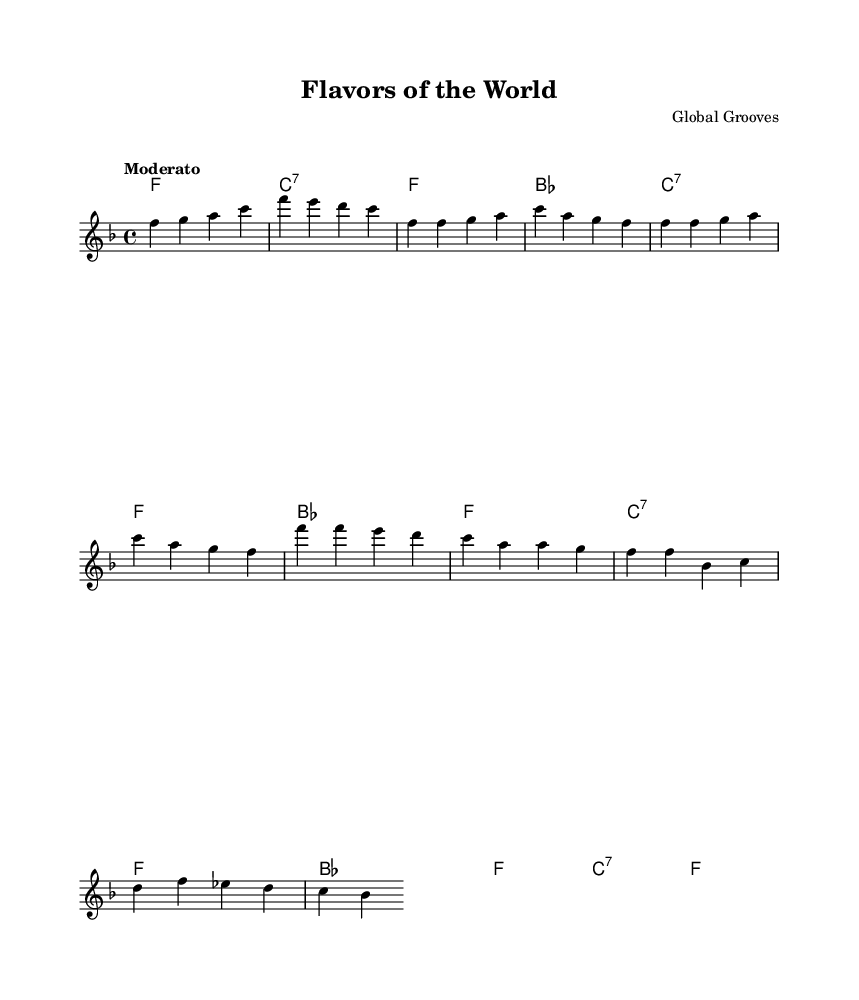What is the key signature of this music? The key signature is F major, which has one flat (B flat).
Answer: F major What is the time signature of this music? The time signature is 4/4, indicating four beats in each measure.
Answer: 4/4 What is the tempo marking for this piece? The tempo marking is "Moderato," which indicates a moderate speed.
Answer: Moderato How many measures are in the chorus section? The chorus section consists of two measures, as indicated by the repeated lines of the lyrics in the score.
Answer: Two Which instruments are indicated in the score layout? The score includes a staff for melody and a section for chord names, typically indicating harmonic support for the melody.
Answer: Melody and chord names What is the main lyrical theme of the song? The song celebrates culinary diversity and global flavors, focusing on the enjoyment of different cuisines.
Answer: Culinary diversity How does the structure of this piece reflect Rhythm and Blues characteristics? The piece combines a catchy melody with a strong, syncopated rhythm and repetitive lyrics, typical traits of Rhythm and Blues music.
Answer: Catchy melody and syncopated rhythm 